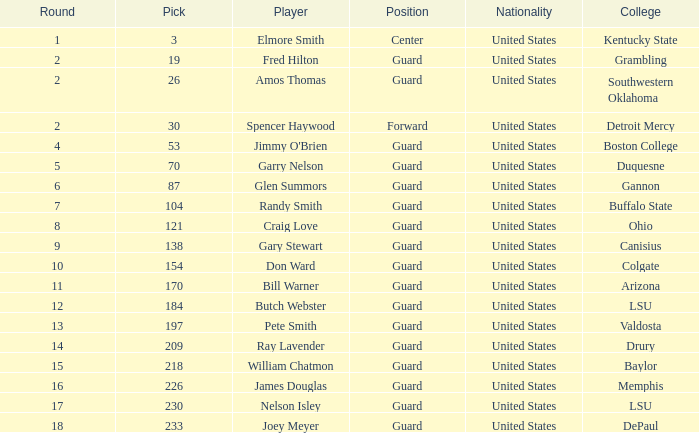WHAT IS THE NATIONALITY FOR SOUTHWESTERN OKLAHOMA? United States. 